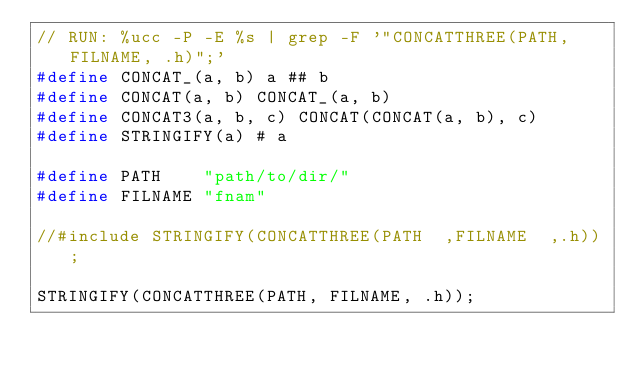Convert code to text. <code><loc_0><loc_0><loc_500><loc_500><_C_>// RUN: %ucc -P -E %s | grep -F '"CONCATTHREE(PATH, FILNAME, .h)";'
#define CONCAT_(a, b) a ## b
#define CONCAT(a, b) CONCAT_(a, b)
#define CONCAT3(a, b, c) CONCAT(CONCAT(a, b), c)
#define STRINGIFY(a) # a

#define PATH    "path/to/dir/"
#define FILNAME "fnam"

//#include STRINGIFY(CONCATTHREE(PATH  ,FILNAME  ,.h));

STRINGIFY(CONCATTHREE(PATH, FILNAME, .h));
</code> 